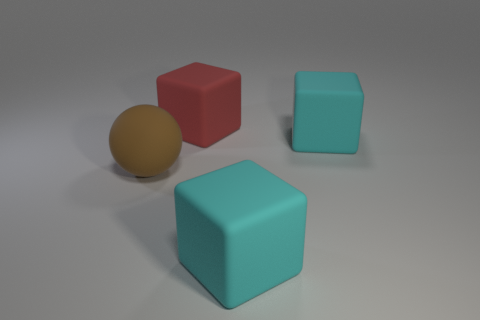Add 4 yellow balls. How many objects exist? 8 Subtract all big cyan rubber blocks. How many blocks are left? 1 Subtract all red cubes. How many cubes are left? 2 Subtract all brown cylinders. How many cyan blocks are left? 2 Subtract all cubes. How many objects are left? 1 Subtract 1 spheres. How many spheres are left? 0 Add 2 cyan things. How many cyan things exist? 4 Subtract 0 red spheres. How many objects are left? 4 Subtract all gray spheres. Subtract all brown cylinders. How many spheres are left? 1 Subtract all red metallic cylinders. Subtract all rubber objects. How many objects are left? 0 